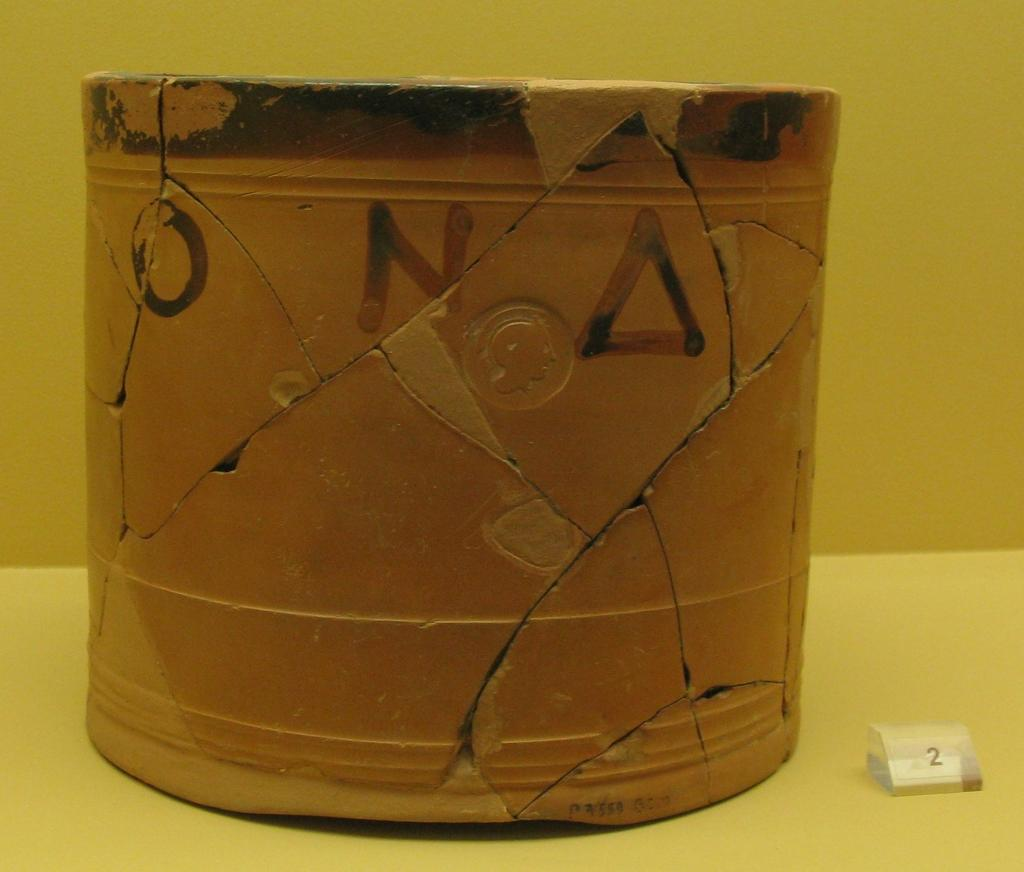<image>
Write a terse but informative summary of the picture. A cracked ceramic pot with Greek lettering on it sits next to a small number 2 display. 